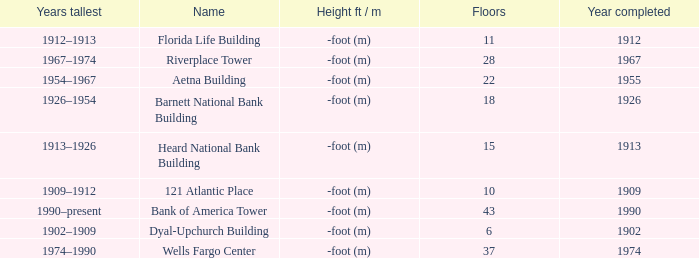What year was the building completed that has 10 floors? 1909.0. I'm looking to parse the entire table for insights. Could you assist me with that? {'header': ['Years tallest', 'Name', 'Height ft / m', 'Floors', 'Year completed'], 'rows': [['1912–1913', 'Florida Life Building', '-foot (m)', '11', '1912'], ['1967–1974', 'Riverplace Tower', '-foot (m)', '28', '1967'], ['1954–1967', 'Aetna Building', '-foot (m)', '22', '1955'], ['1926–1954', 'Barnett National Bank Building', '-foot (m)', '18', '1926'], ['1913–1926', 'Heard National Bank Building', '-foot (m)', '15', '1913'], ['1909–1912', '121 Atlantic Place', '-foot (m)', '10', '1909'], ['1990–present', 'Bank of America Tower', '-foot (m)', '43', '1990'], ['1902–1909', 'Dyal-Upchurch Building', '-foot (m)', '6', '1902'], ['1974–1990', 'Wells Fargo Center', '-foot (m)', '37', '1974']]} 